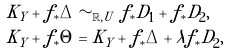Convert formula to latex. <formula><loc_0><loc_0><loc_500><loc_500>K _ { Y } + f _ { * } \Delta & \sim _ { \mathbb { R } , U } f _ { * } D _ { 1 } + f _ { * } D _ { 2 } , \\ K _ { Y } + f _ { * } \Theta & = K _ { Y } + f _ { * } \Delta + \lambda f _ { * } D _ { 2 } ,</formula> 